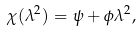<formula> <loc_0><loc_0><loc_500><loc_500>\chi ( \lambda ^ { 2 } ) = \psi + \phi \lambda ^ { 2 } ,</formula> 